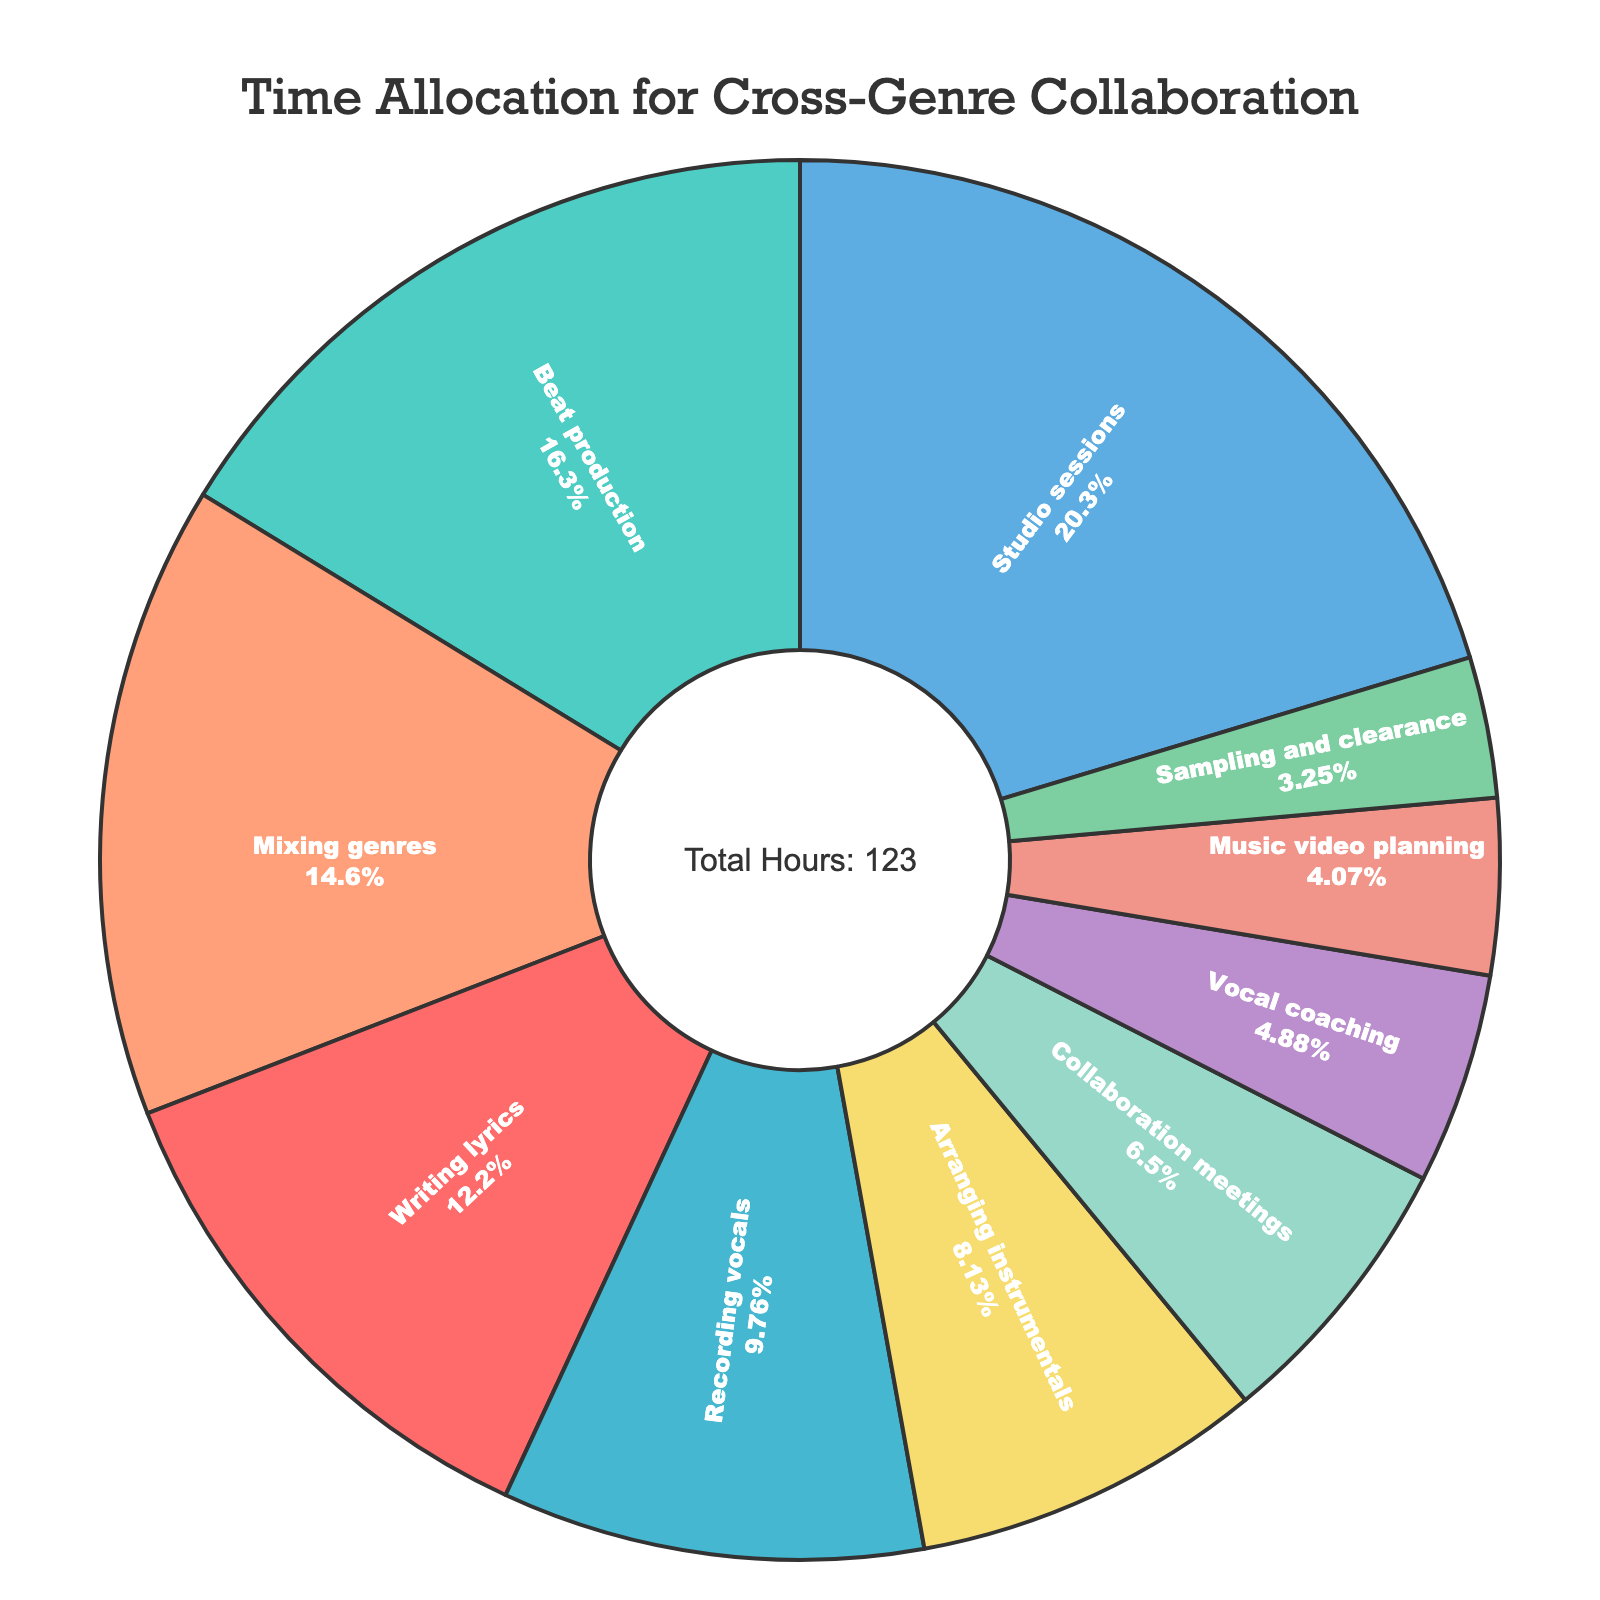What's the largest allocation of time in the pie chart? The largest allocation of time can be observed by identifying the largest slice in the pie chart. The largest slice represents "Studio sessions".
Answer: Studio sessions Which activities have a close allocation of time based on the visual size of their slices? By observing the pie chart, we can see that the slices for "Mixing genres" and "Writing lyrics" appear to be close in size. Similarly, "Arranging instrumentals" and "Recording vocals" also have similar sizes.
Answer: Mixing genres and Writing lyrics; Arranging instrumentals and Recording vocals What activity has the smallest allocation of time and how much time is allocated to it? The smallest slice in the pie chart represents "Sampling and clearance". The amount of time allocated to this activity is 4 hours.
Answer: Sampling and clearance, 4 hours How much time in total is dedicated to writing lyrics, beat production, and recording vocals combined? To find the total time, add the hours allocated to each of these activities: 15 (Writing lyrics) + 20 (Beat production) + 12 (Recording vocals). Therefore, the total time is 47 hours.
Answer: 47 hours Compare the time allocated to studio sessions versus collaboration meetings. Studio sessions are allocated 25 hours, while collaboration meetings are allocated 8 hours. By comparing these two, studio sessions have significantly more time allocated.
Answer: Studio sessions have more time Which activity occupies a middle value in the range of time allocations? Arranging instrumentals, with 10 hours, appears to be in the middle range of the various time allocations, as it neither has the highest nor the lowest hours.
Answer: Arranging instrumentals How does the time for writing lyrics compare to vocal coaching in terms of the percentage of the total time? Writing lyrics are allocated 15 hours, and vocal coaching is allocated 6 hours. Considering the total hours are 123, writing lyrics take up about 12.2% (15/123*100) and vocal coaching takes up about 4.9% (6/123*100). Therefore, writing lyrics occupy a higher percentage.
Answer: Writing lyrics have a higher percentage What is the difference in time allocation between mixing genres and music video planning? Mixing genres is allocated 18 hours, while music video planning is allocated 5 hours. The difference between these two is 18 - 5 = 13 hours.
Answer: 13 hours Which activities are allocated more than 10 hours but less than 20 hours? From the pie chart, the activities that meet this criterion are "Writing lyrics" with 15 hours, "Mixing genres" with 18 hours, and "Arranging instrumentals" with 10 hours.
Answer: Writing lyrics, Mixing genres, Arranging instrumentals What is the average time allocation across all listed activities? The total time allocated is 123 hours, and there are 10 activities in total. The average time allocation is 123/10 = 12.3 hours.
Answer: 12.3 hours 